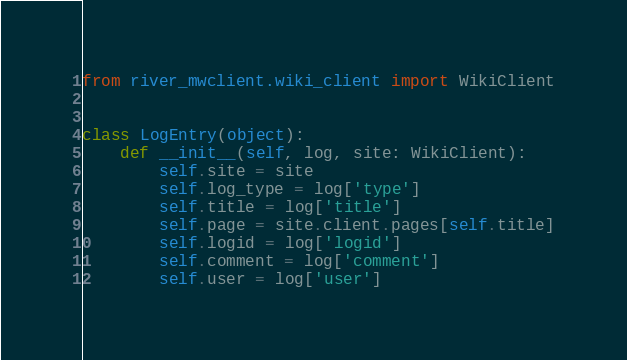Convert code to text. <code><loc_0><loc_0><loc_500><loc_500><_Python_>from river_mwclient.wiki_client import WikiClient


class LogEntry(object):
    def __init__(self, log, site: WikiClient):
        self.site = site
        self.log_type = log['type']
        self.title = log['title']
        self.page = site.client.pages[self.title]
        self.logid = log['logid']
        self.comment = log['comment']
        self.user = log['user']
</code> 